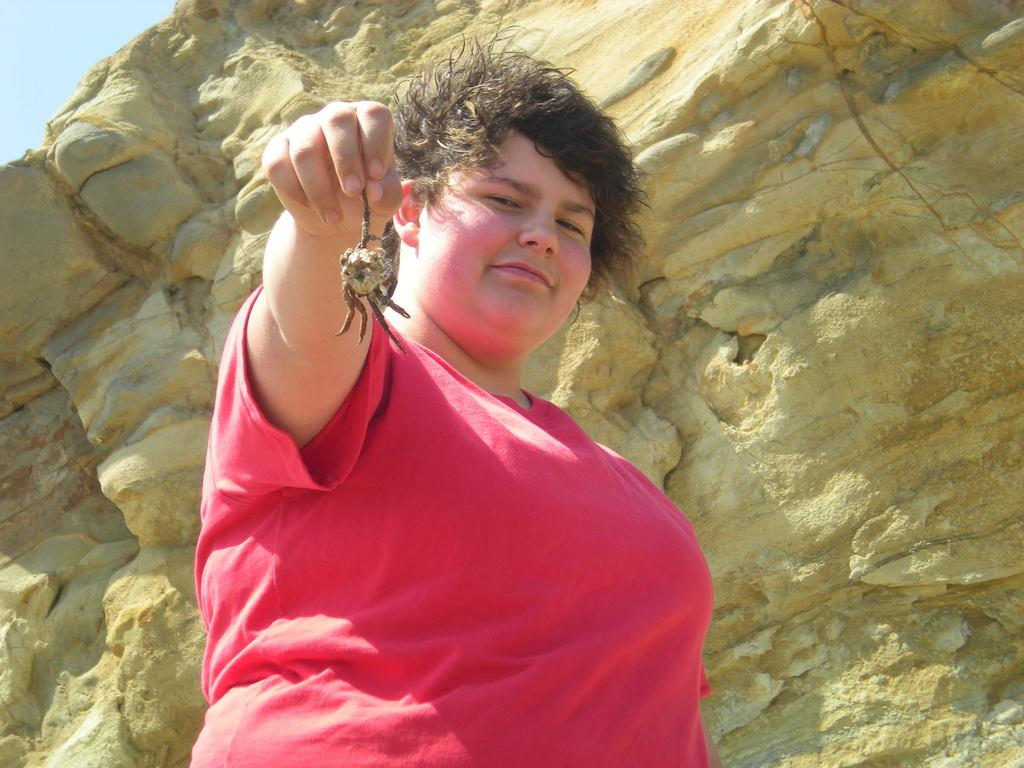What is the person in the image doing? The person is standing in the image and holding an insect. Can you describe the insect the person is holding? Unfortunately, the specific type of insect cannot be determined from the image. What can be seen in the background of the image? There is a rock and the sky visible in the background of the image. What type of cake is being served at the event in the image? There is no event or cake present in the image; it features a person holding an insect. 